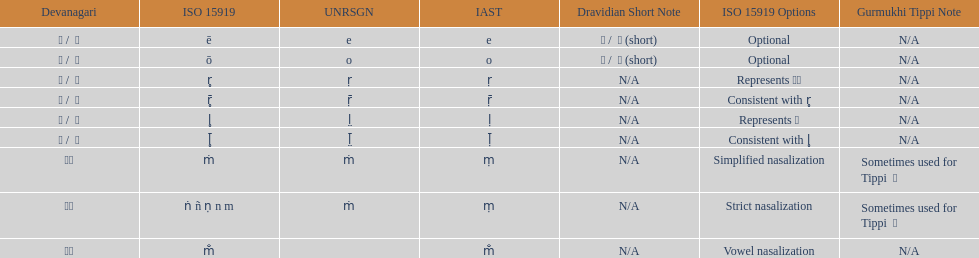What unrsgn is listed previous to the o? E. 